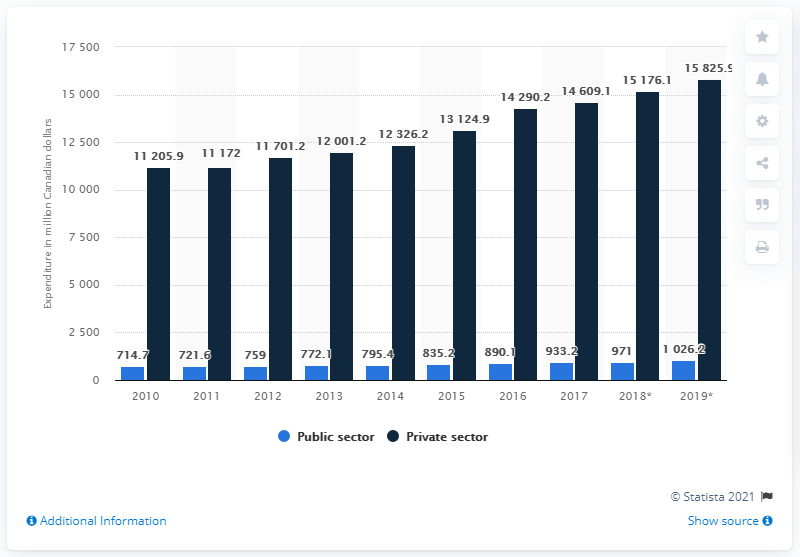Point out several critical features in this image. In 2010, the public sector in Canada spent approximately CAD 714.7 million on dental services. In 2010, the private sector in Canada spent a total of CAD 11,205.9 on dental services. 